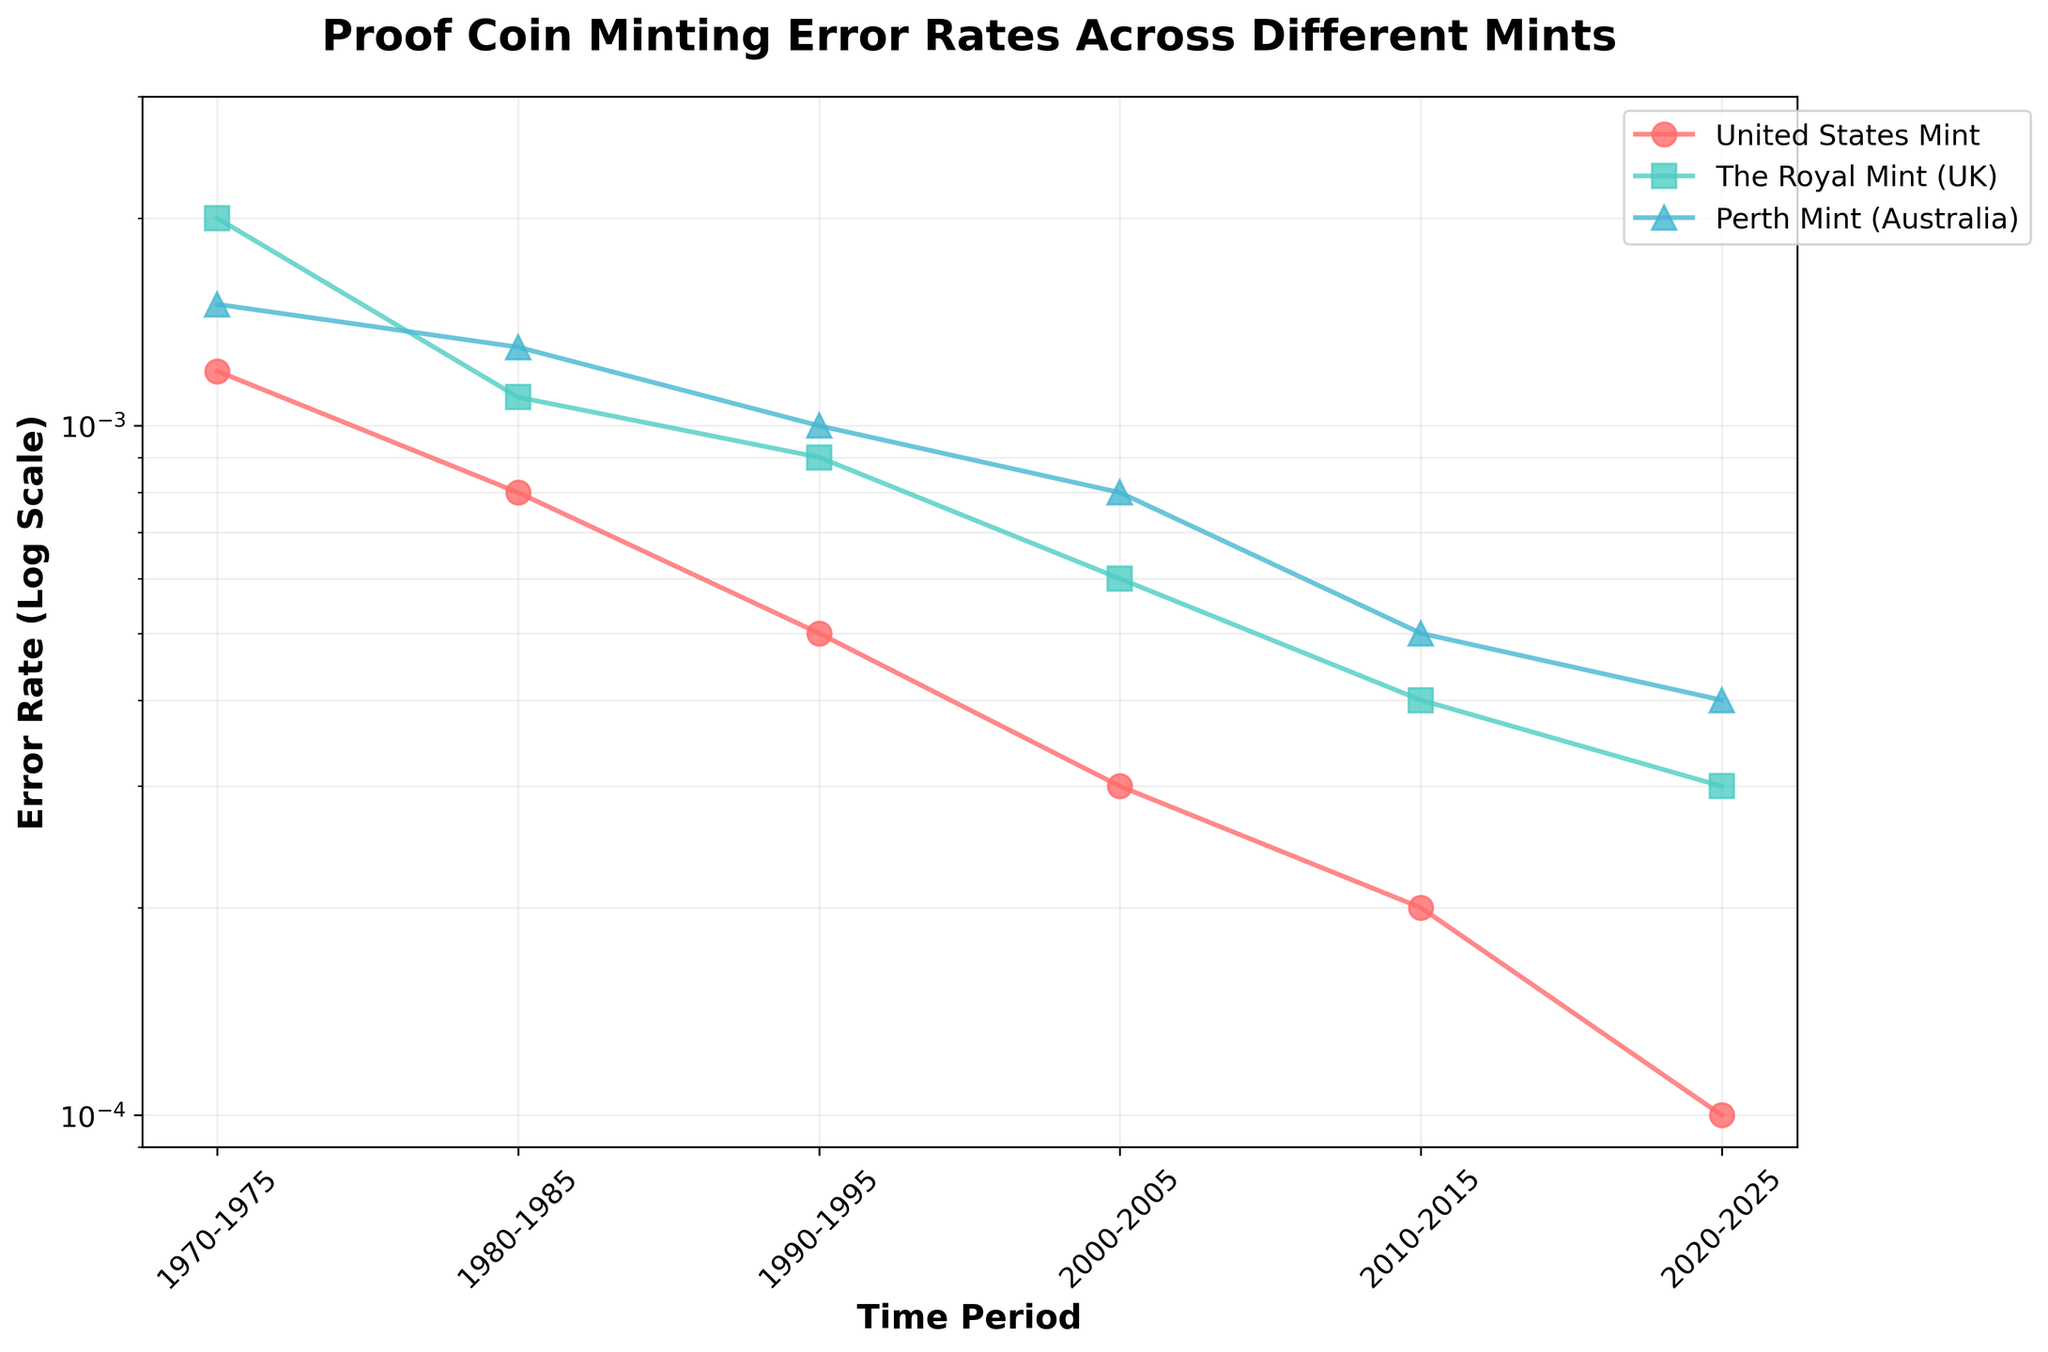what is the title of the figure? The title is written at the top of the figure. It reads: "Proof Coin Minting Error Rates Across Different Mints"
Answer: Proof Coin Minting Error Rates Across Different Mints How many mints are compared in the figure? The legend on the right side of the figure lists the mints being compared. There are three mints.
Answer: Three During which time period did the United States Mint have the highest error rate? Look at the line representing the United States Mint. The highest point on the graph for this line appears during the time period 1970-1975.
Answer: 1970-1975 Which mint had the lowest error rate in the 2000-2005 period? Find the data points in the 2000-2005 period and compare their positions. The United States Mint has the lowest point on the y-axis during this period.
Answer: United States Mint Has the error rate for the Perth Mint increased or decreased over time? Observe the trend of the line representing the Perth Mint. The line generally moves downward, indicating a decrease.
Answer: Decreased Compare the error rates of the Royal Mint (UK) and the Perth Mint in the period 1990-1995. Which mint had a higher error rate? Find the points for the Royal Mint (UK) and the Perth Mint in this period. The Royal Mint (UK) has a higher position on the y-axis, indicating a higher error rate.
Answer: The Royal Mint (UK) By what factor did the error rate decrease for the United States Mint from 1970-1975 to 2010-2015? Note the error rates: 0.0012 in 1970-1975 and 0.0002 in 2010-2015. The decrease factor is 0.0012 / 0.0002 = 6.
Answer: 6 Which time period shows the greatest reduction in error rate for the Perth Mint? Compare the error rates across successive periods. The largest reduction is from 2000-2005 (0.0008) to 2010-2015 (0.0005).
Answer: 2000-2005 to 2010-2015 Between 1980-1985 and 1990-1995, how much did the error rate reduce for the Royal Mint? Note the error rates: 0.0011 in 1980-1985 and 0.0009 in 1990-1995. Subtract 0.0009 from 0.0011 to get the reduction.
Answer: 0.0002 